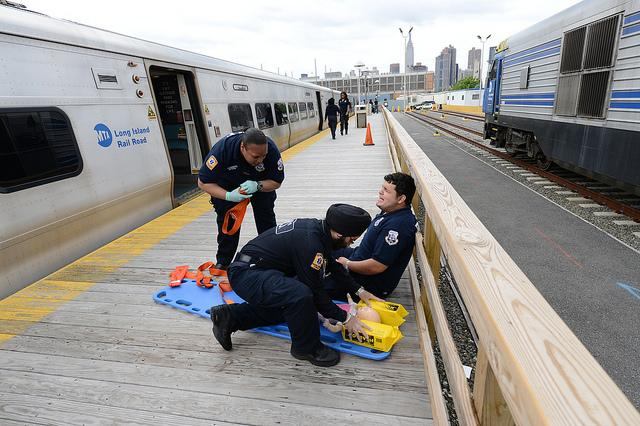Which major US city does this train line service? Please explain your reasoning. new york. The logo of the train says mta for new york. 